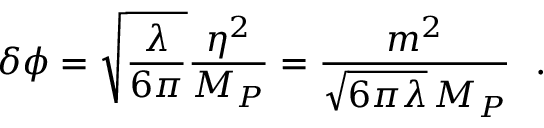<formula> <loc_0><loc_0><loc_500><loc_500>\delta \phi = \sqrt { \frac { \lambda } { 6 \pi } } { \frac { \eta ^ { 2 } } { M _ { P } } } = { \frac { m ^ { 2 } } { \sqrt { 6 \pi \lambda } \, M _ { P } } } \ .</formula> 